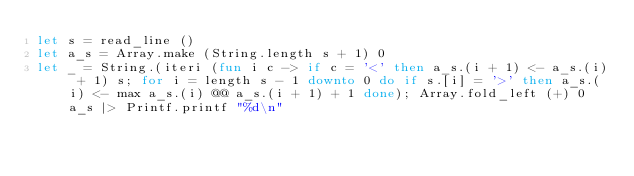<code> <loc_0><loc_0><loc_500><loc_500><_OCaml_>let s = read_line ()
let a_s = Array.make (String.length s + 1) 0
let _ = String.(iteri (fun i c -> if c = '<' then a_s.(i + 1) <- a_s.(i) + 1) s; for i = length s - 1 downto 0 do if s.[i] = '>' then a_s.(i) <- max a_s.(i) @@ a_s.(i + 1) + 1 done); Array.fold_left (+) 0 a_s |> Printf.printf "%d\n"</code> 